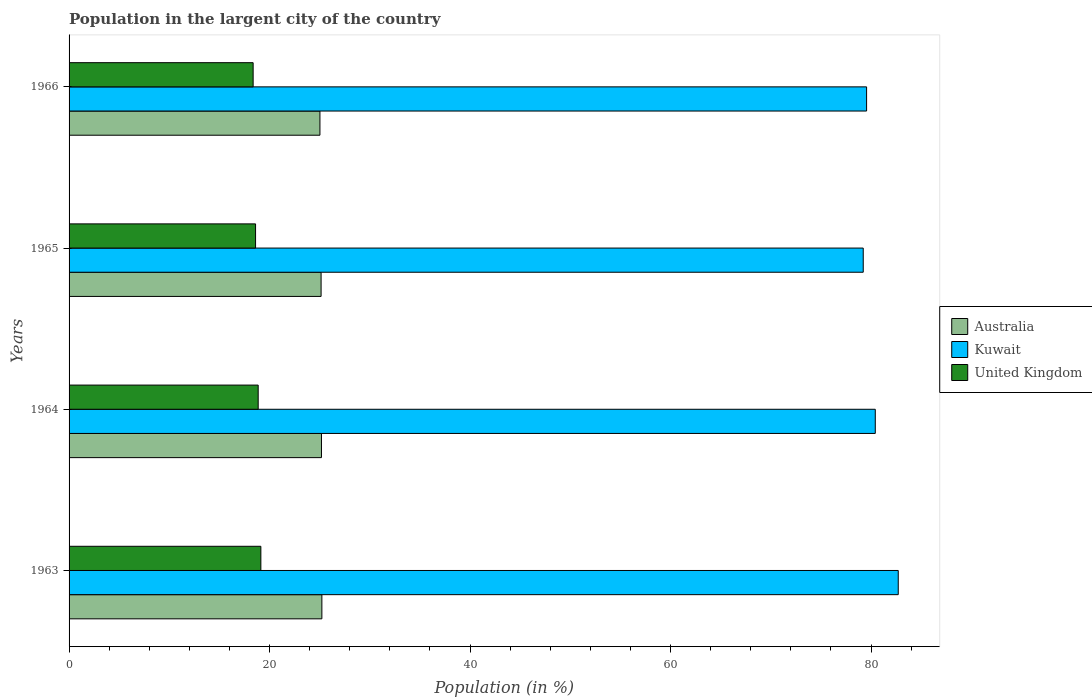How many different coloured bars are there?
Give a very brief answer. 3. Are the number of bars on each tick of the Y-axis equal?
Give a very brief answer. Yes. How many bars are there on the 3rd tick from the top?
Offer a very short reply. 3. How many bars are there on the 1st tick from the bottom?
Your answer should be very brief. 3. What is the label of the 3rd group of bars from the top?
Offer a very short reply. 1964. What is the percentage of population in the largent city in United Kingdom in 1964?
Your response must be concise. 18.87. Across all years, what is the maximum percentage of population in the largent city in United Kingdom?
Provide a succinct answer. 19.13. Across all years, what is the minimum percentage of population in the largent city in Kuwait?
Your answer should be compact. 79.22. In which year was the percentage of population in the largent city in Australia minimum?
Make the answer very short. 1966. What is the total percentage of population in the largent city in United Kingdom in the graph?
Your answer should be compact. 74.97. What is the difference between the percentage of population in the largent city in United Kingdom in 1963 and that in 1964?
Provide a short and direct response. 0.27. What is the difference between the percentage of population in the largent city in Australia in 1966 and the percentage of population in the largent city in United Kingdom in 1963?
Keep it short and to the point. 5.89. What is the average percentage of population in the largent city in Australia per year?
Give a very brief answer. 25.14. In the year 1966, what is the difference between the percentage of population in the largent city in Australia and percentage of population in the largent city in United Kingdom?
Offer a terse response. 6.66. In how many years, is the percentage of population in the largent city in Australia greater than 16 %?
Provide a short and direct response. 4. What is the ratio of the percentage of population in the largent city in Kuwait in 1964 to that in 1966?
Your response must be concise. 1.01. Is the percentage of population in the largent city in Australia in 1964 less than that in 1965?
Your answer should be compact. No. What is the difference between the highest and the second highest percentage of population in the largent city in Australia?
Make the answer very short. 0.04. What is the difference between the highest and the lowest percentage of population in the largent city in Australia?
Your answer should be compact. 0.19. Is the sum of the percentage of population in the largent city in Kuwait in 1963 and 1965 greater than the maximum percentage of population in the largent city in Australia across all years?
Make the answer very short. Yes. How many bars are there?
Offer a very short reply. 12. Are all the bars in the graph horizontal?
Keep it short and to the point. Yes. How many years are there in the graph?
Keep it short and to the point. 4. Does the graph contain any zero values?
Keep it short and to the point. No. Does the graph contain grids?
Ensure brevity in your answer.  No. Where does the legend appear in the graph?
Provide a succinct answer. Center right. How are the legend labels stacked?
Offer a terse response. Vertical. What is the title of the graph?
Offer a terse response. Population in the largent city of the country. Does "Colombia" appear as one of the legend labels in the graph?
Give a very brief answer. No. What is the label or title of the Y-axis?
Make the answer very short. Years. What is the Population (in %) in Australia in 1963?
Provide a short and direct response. 25.22. What is the Population (in %) in Kuwait in 1963?
Provide a short and direct response. 82.72. What is the Population (in %) in United Kingdom in 1963?
Offer a very short reply. 19.13. What is the Population (in %) of Australia in 1964?
Offer a terse response. 25.18. What is the Population (in %) of Kuwait in 1964?
Keep it short and to the point. 80.43. What is the Population (in %) of United Kingdom in 1964?
Offer a terse response. 18.87. What is the Population (in %) of Australia in 1965?
Your answer should be very brief. 25.14. What is the Population (in %) of Kuwait in 1965?
Ensure brevity in your answer.  79.22. What is the Population (in %) of United Kingdom in 1965?
Give a very brief answer. 18.6. What is the Population (in %) in Australia in 1966?
Ensure brevity in your answer.  25.03. What is the Population (in %) of Kuwait in 1966?
Provide a succinct answer. 79.56. What is the Population (in %) in United Kingdom in 1966?
Provide a succinct answer. 18.36. Across all years, what is the maximum Population (in %) of Australia?
Your response must be concise. 25.22. Across all years, what is the maximum Population (in %) of Kuwait?
Provide a short and direct response. 82.72. Across all years, what is the maximum Population (in %) in United Kingdom?
Your answer should be compact. 19.13. Across all years, what is the minimum Population (in %) in Australia?
Ensure brevity in your answer.  25.03. Across all years, what is the minimum Population (in %) in Kuwait?
Keep it short and to the point. 79.22. Across all years, what is the minimum Population (in %) of United Kingdom?
Give a very brief answer. 18.36. What is the total Population (in %) of Australia in the graph?
Keep it short and to the point. 100.57. What is the total Population (in %) in Kuwait in the graph?
Make the answer very short. 321.93. What is the total Population (in %) of United Kingdom in the graph?
Provide a succinct answer. 74.97. What is the difference between the Population (in %) in Australia in 1963 and that in 1964?
Your response must be concise. 0.04. What is the difference between the Population (in %) of Kuwait in 1963 and that in 1964?
Your response must be concise. 2.29. What is the difference between the Population (in %) in United Kingdom in 1963 and that in 1964?
Your answer should be very brief. 0.27. What is the difference between the Population (in %) in Australia in 1963 and that in 1965?
Keep it short and to the point. 0.08. What is the difference between the Population (in %) of Kuwait in 1963 and that in 1965?
Make the answer very short. 3.49. What is the difference between the Population (in %) of United Kingdom in 1963 and that in 1965?
Provide a short and direct response. 0.53. What is the difference between the Population (in %) in Australia in 1963 and that in 1966?
Offer a very short reply. 0.19. What is the difference between the Population (in %) in Kuwait in 1963 and that in 1966?
Offer a very short reply. 3.16. What is the difference between the Population (in %) in United Kingdom in 1963 and that in 1966?
Make the answer very short. 0.77. What is the difference between the Population (in %) in Australia in 1964 and that in 1965?
Your answer should be compact. 0.04. What is the difference between the Population (in %) of Kuwait in 1964 and that in 1965?
Give a very brief answer. 1.2. What is the difference between the Population (in %) in United Kingdom in 1964 and that in 1965?
Provide a succinct answer. 0.26. What is the difference between the Population (in %) of Australia in 1964 and that in 1966?
Provide a short and direct response. 0.15. What is the difference between the Population (in %) of Kuwait in 1964 and that in 1966?
Your response must be concise. 0.87. What is the difference between the Population (in %) of United Kingdom in 1964 and that in 1966?
Make the answer very short. 0.5. What is the difference between the Population (in %) in Australia in 1965 and that in 1966?
Your answer should be compact. 0.12. What is the difference between the Population (in %) in Kuwait in 1965 and that in 1966?
Your answer should be compact. -0.34. What is the difference between the Population (in %) in United Kingdom in 1965 and that in 1966?
Your answer should be very brief. 0.24. What is the difference between the Population (in %) of Australia in 1963 and the Population (in %) of Kuwait in 1964?
Your answer should be very brief. -55.21. What is the difference between the Population (in %) in Australia in 1963 and the Population (in %) in United Kingdom in 1964?
Your answer should be compact. 6.35. What is the difference between the Population (in %) of Kuwait in 1963 and the Population (in %) of United Kingdom in 1964?
Give a very brief answer. 63.85. What is the difference between the Population (in %) of Australia in 1963 and the Population (in %) of Kuwait in 1965?
Offer a terse response. -54.01. What is the difference between the Population (in %) of Australia in 1963 and the Population (in %) of United Kingdom in 1965?
Ensure brevity in your answer.  6.62. What is the difference between the Population (in %) of Kuwait in 1963 and the Population (in %) of United Kingdom in 1965?
Give a very brief answer. 64.11. What is the difference between the Population (in %) in Australia in 1963 and the Population (in %) in Kuwait in 1966?
Your answer should be very brief. -54.34. What is the difference between the Population (in %) of Australia in 1963 and the Population (in %) of United Kingdom in 1966?
Make the answer very short. 6.86. What is the difference between the Population (in %) in Kuwait in 1963 and the Population (in %) in United Kingdom in 1966?
Keep it short and to the point. 64.36. What is the difference between the Population (in %) of Australia in 1964 and the Population (in %) of Kuwait in 1965?
Offer a very short reply. -54.05. What is the difference between the Population (in %) in Australia in 1964 and the Population (in %) in United Kingdom in 1965?
Keep it short and to the point. 6.58. What is the difference between the Population (in %) of Kuwait in 1964 and the Population (in %) of United Kingdom in 1965?
Keep it short and to the point. 61.82. What is the difference between the Population (in %) in Australia in 1964 and the Population (in %) in Kuwait in 1966?
Make the answer very short. -54.38. What is the difference between the Population (in %) in Australia in 1964 and the Population (in %) in United Kingdom in 1966?
Provide a short and direct response. 6.82. What is the difference between the Population (in %) of Kuwait in 1964 and the Population (in %) of United Kingdom in 1966?
Your answer should be compact. 62.06. What is the difference between the Population (in %) of Australia in 1965 and the Population (in %) of Kuwait in 1966?
Keep it short and to the point. -54.42. What is the difference between the Population (in %) in Australia in 1965 and the Population (in %) in United Kingdom in 1966?
Offer a very short reply. 6.78. What is the difference between the Population (in %) of Kuwait in 1965 and the Population (in %) of United Kingdom in 1966?
Offer a very short reply. 60.86. What is the average Population (in %) in Australia per year?
Provide a succinct answer. 25.14. What is the average Population (in %) of Kuwait per year?
Give a very brief answer. 80.48. What is the average Population (in %) in United Kingdom per year?
Offer a very short reply. 18.74. In the year 1963, what is the difference between the Population (in %) in Australia and Population (in %) in Kuwait?
Make the answer very short. -57.5. In the year 1963, what is the difference between the Population (in %) of Australia and Population (in %) of United Kingdom?
Make the answer very short. 6.09. In the year 1963, what is the difference between the Population (in %) of Kuwait and Population (in %) of United Kingdom?
Offer a terse response. 63.58. In the year 1964, what is the difference between the Population (in %) in Australia and Population (in %) in Kuwait?
Make the answer very short. -55.25. In the year 1964, what is the difference between the Population (in %) in Australia and Population (in %) in United Kingdom?
Your answer should be very brief. 6.31. In the year 1964, what is the difference between the Population (in %) in Kuwait and Population (in %) in United Kingdom?
Ensure brevity in your answer.  61.56. In the year 1965, what is the difference between the Population (in %) of Australia and Population (in %) of Kuwait?
Keep it short and to the point. -54.08. In the year 1965, what is the difference between the Population (in %) in Australia and Population (in %) in United Kingdom?
Provide a short and direct response. 6.54. In the year 1965, what is the difference between the Population (in %) in Kuwait and Population (in %) in United Kingdom?
Keep it short and to the point. 60.62. In the year 1966, what is the difference between the Population (in %) in Australia and Population (in %) in Kuwait?
Provide a short and direct response. -54.53. In the year 1966, what is the difference between the Population (in %) in Australia and Population (in %) in United Kingdom?
Provide a succinct answer. 6.66. In the year 1966, what is the difference between the Population (in %) of Kuwait and Population (in %) of United Kingdom?
Offer a terse response. 61.2. What is the ratio of the Population (in %) of Kuwait in 1963 to that in 1964?
Offer a terse response. 1.03. What is the ratio of the Population (in %) in United Kingdom in 1963 to that in 1964?
Offer a terse response. 1.01. What is the ratio of the Population (in %) in Australia in 1963 to that in 1965?
Offer a very short reply. 1. What is the ratio of the Population (in %) of Kuwait in 1963 to that in 1965?
Ensure brevity in your answer.  1.04. What is the ratio of the Population (in %) in United Kingdom in 1963 to that in 1965?
Give a very brief answer. 1.03. What is the ratio of the Population (in %) of Australia in 1963 to that in 1966?
Your response must be concise. 1.01. What is the ratio of the Population (in %) of Kuwait in 1963 to that in 1966?
Ensure brevity in your answer.  1.04. What is the ratio of the Population (in %) of United Kingdom in 1963 to that in 1966?
Offer a terse response. 1.04. What is the ratio of the Population (in %) in Australia in 1964 to that in 1965?
Offer a very short reply. 1. What is the ratio of the Population (in %) in Kuwait in 1964 to that in 1965?
Your response must be concise. 1.02. What is the ratio of the Population (in %) of United Kingdom in 1964 to that in 1965?
Make the answer very short. 1.01. What is the ratio of the Population (in %) of Australia in 1964 to that in 1966?
Keep it short and to the point. 1.01. What is the ratio of the Population (in %) in Kuwait in 1964 to that in 1966?
Ensure brevity in your answer.  1.01. What is the ratio of the Population (in %) in United Kingdom in 1964 to that in 1966?
Give a very brief answer. 1.03. What is the ratio of the Population (in %) in Kuwait in 1965 to that in 1966?
Provide a succinct answer. 1. What is the ratio of the Population (in %) in United Kingdom in 1965 to that in 1966?
Offer a terse response. 1.01. What is the difference between the highest and the second highest Population (in %) in Australia?
Give a very brief answer. 0.04. What is the difference between the highest and the second highest Population (in %) of Kuwait?
Provide a succinct answer. 2.29. What is the difference between the highest and the second highest Population (in %) in United Kingdom?
Give a very brief answer. 0.27. What is the difference between the highest and the lowest Population (in %) of Australia?
Your response must be concise. 0.19. What is the difference between the highest and the lowest Population (in %) in Kuwait?
Offer a very short reply. 3.49. What is the difference between the highest and the lowest Population (in %) of United Kingdom?
Offer a very short reply. 0.77. 